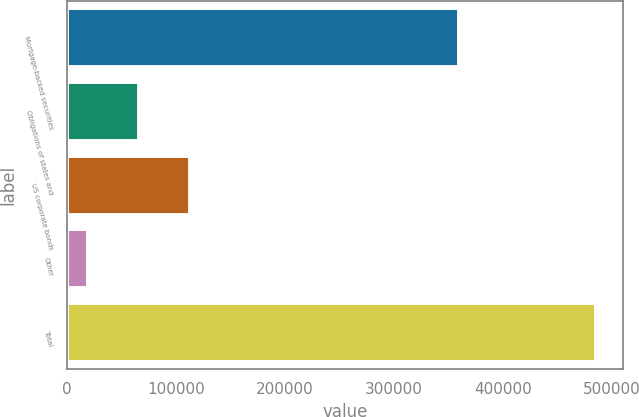Convert chart. <chart><loc_0><loc_0><loc_500><loc_500><bar_chart><fcel>Mortgage-backed securities<fcel>Obligations of states and<fcel>US corporate bonds<fcel>Other<fcel>Total<nl><fcel>359809<fcel>66129.9<fcel>112739<fcel>19521<fcel>485610<nl></chart> 